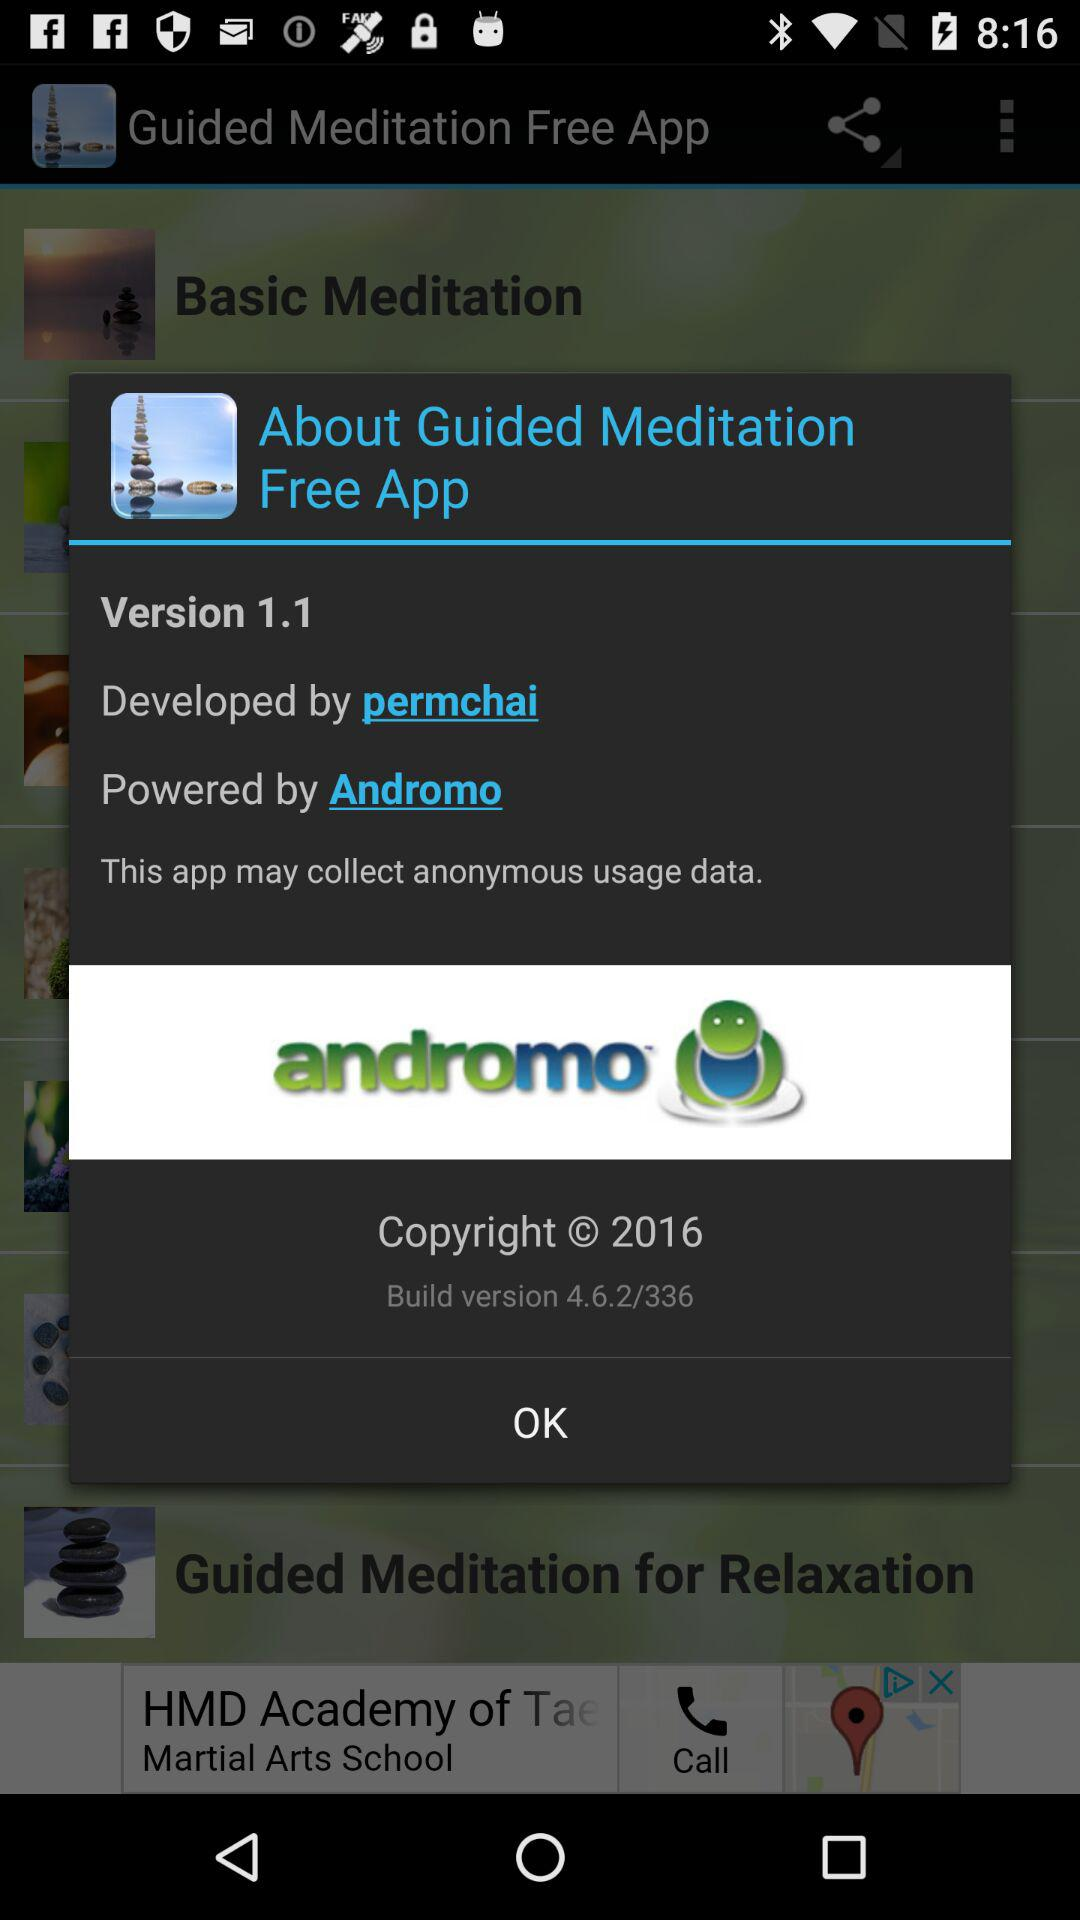"Guided Meditation Free App" is powered by what platform? The platform is "Andromo". 